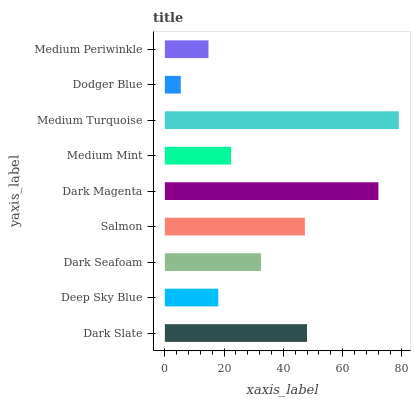Is Dodger Blue the minimum?
Answer yes or no. Yes. Is Medium Turquoise the maximum?
Answer yes or no. Yes. Is Deep Sky Blue the minimum?
Answer yes or no. No. Is Deep Sky Blue the maximum?
Answer yes or no. No. Is Dark Slate greater than Deep Sky Blue?
Answer yes or no. Yes. Is Deep Sky Blue less than Dark Slate?
Answer yes or no. Yes. Is Deep Sky Blue greater than Dark Slate?
Answer yes or no. No. Is Dark Slate less than Deep Sky Blue?
Answer yes or no. No. Is Dark Seafoam the high median?
Answer yes or no. Yes. Is Dark Seafoam the low median?
Answer yes or no. Yes. Is Dark Slate the high median?
Answer yes or no. No. Is Medium Turquoise the low median?
Answer yes or no. No. 